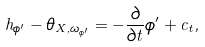<formula> <loc_0><loc_0><loc_500><loc_500>h _ { \phi ^ { \prime } } - \theta _ { X , \omega _ { \phi ^ { \prime } } } = - \frac { \partial } { \partial t } \phi ^ { \prime } + c _ { t } ,</formula> 